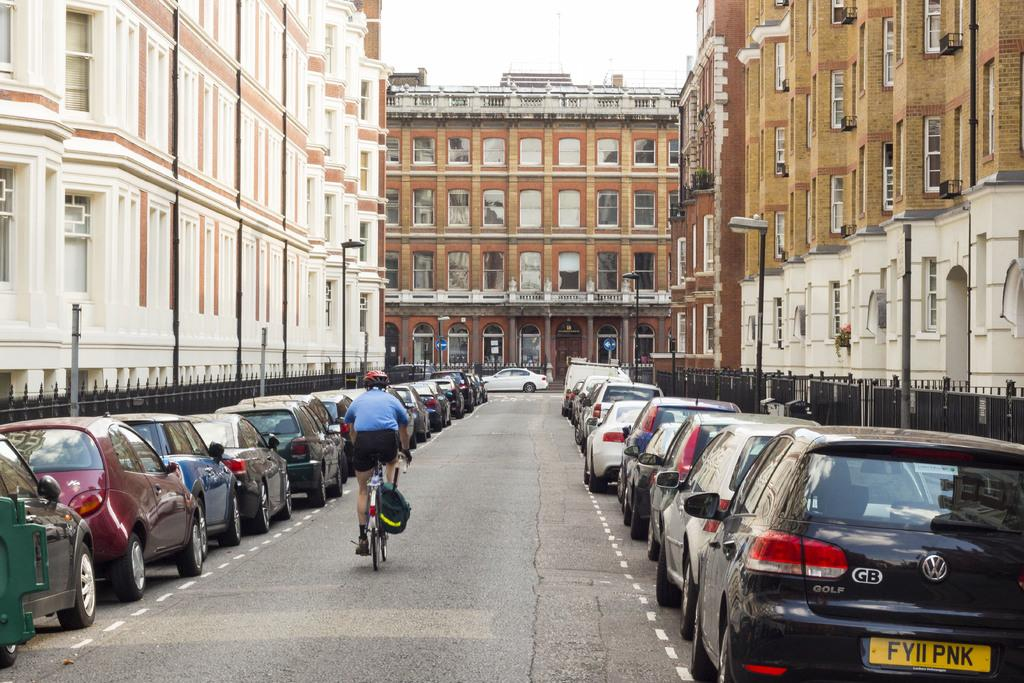What is the person in the image doing? The person is riding a bicycle. What safety precaution is the person taking while riding the bicycle? The person is wearing a helmet. What type of structures can be seen in the background of the image? There are buildings visible in the image. What are the lights on poles used for in the image? The lights on poles are likely used for illumination at night or in low-light conditions. What part of the natural environment is visible in the image? The sky is visible in the image. What color is the rhythm of the blade in the image? There is no rhythm or blade present in the image; it features a person riding a bicycle with a helmet, buildings, lights on poles, and a visible sky. 